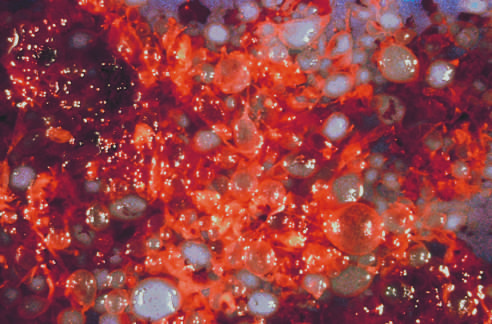what consists of numerous swollen villi?
Answer the question using a single word or phrase. Complete hydatidiform mole 